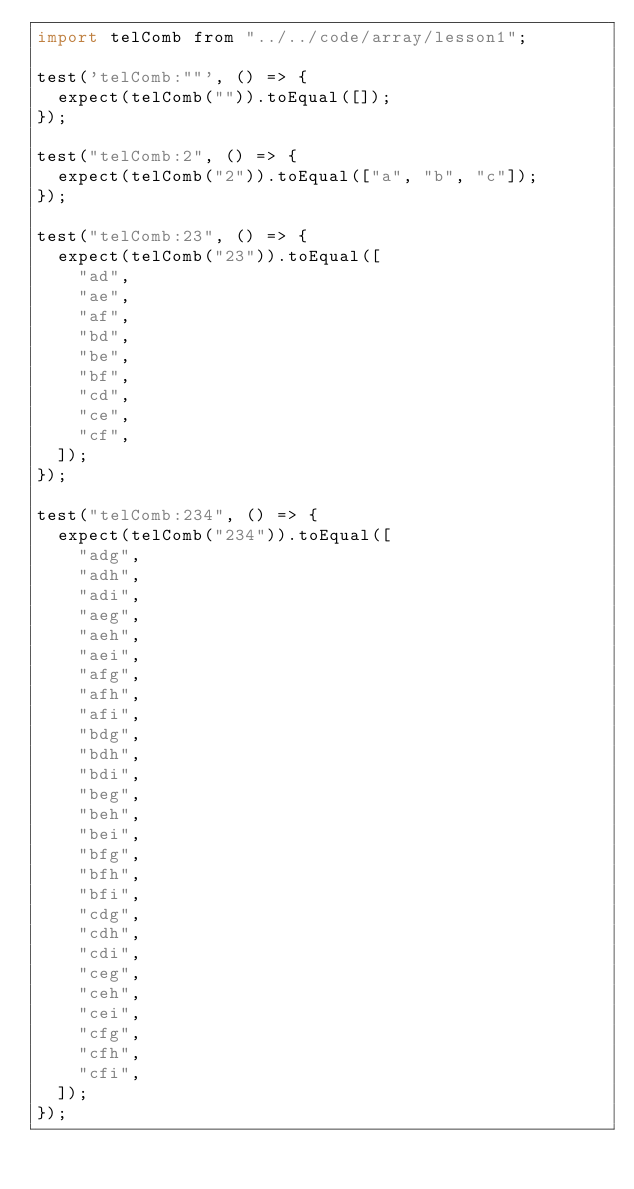<code> <loc_0><loc_0><loc_500><loc_500><_JavaScript_>import telComb from "../../code/array/lesson1";

test('telComb:""', () => {
	expect(telComb("")).toEqual([]);
});

test("telComb:2", () => {
	expect(telComb("2")).toEqual(["a", "b", "c"]);
});

test("telComb:23", () => {
	expect(telComb("23")).toEqual([
		"ad",
		"ae",
		"af",
		"bd",
		"be",
		"bf",
		"cd",
		"ce",
		"cf",
	]);
});

test("telComb:234", () => {
	expect(telComb("234")).toEqual([
		"adg",
		"adh",
		"adi",
		"aeg",
		"aeh",
		"aei",
		"afg",
		"afh",
		"afi",
		"bdg",
		"bdh",
		"bdi",
		"beg",
		"beh",
		"bei",
		"bfg",
		"bfh",
		"bfi",
		"cdg",
		"cdh",
		"cdi",
		"ceg",
		"ceh",
		"cei",
		"cfg",
		"cfh",
		"cfi",
	]);
});
</code> 